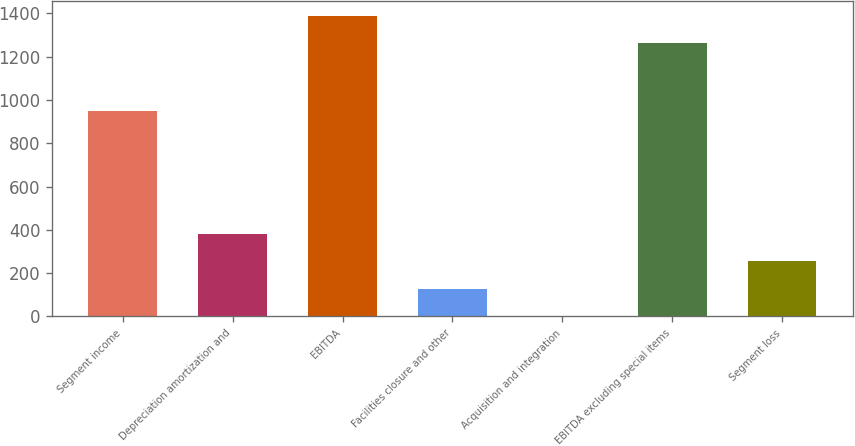Convert chart to OTSL. <chart><loc_0><loc_0><loc_500><loc_500><bar_chart><fcel>Segment income<fcel>Depreciation amortization and<fcel>EBITDA<fcel>Facilities closure and other<fcel>Acquisition and integration<fcel>EBITDA excluding special items<fcel>Segment loss<nl><fcel>950.3<fcel>381.53<fcel>1390.31<fcel>128.31<fcel>1.7<fcel>1263.7<fcel>254.92<nl></chart> 